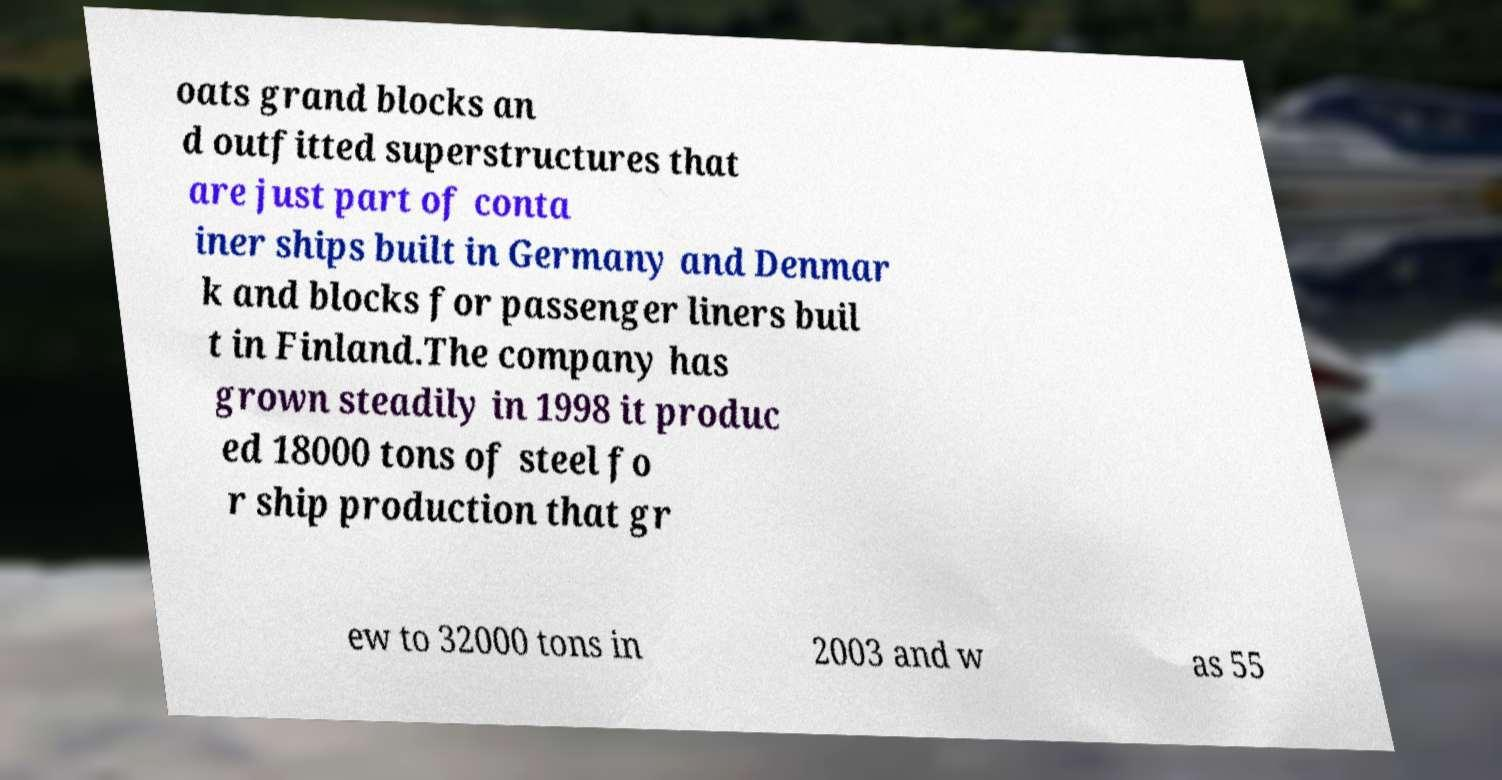Please identify and transcribe the text found in this image. oats grand blocks an d outfitted superstructures that are just part of conta iner ships built in Germany and Denmar k and blocks for passenger liners buil t in Finland.The company has grown steadily in 1998 it produc ed 18000 tons of steel fo r ship production that gr ew to 32000 tons in 2003 and w as 55 